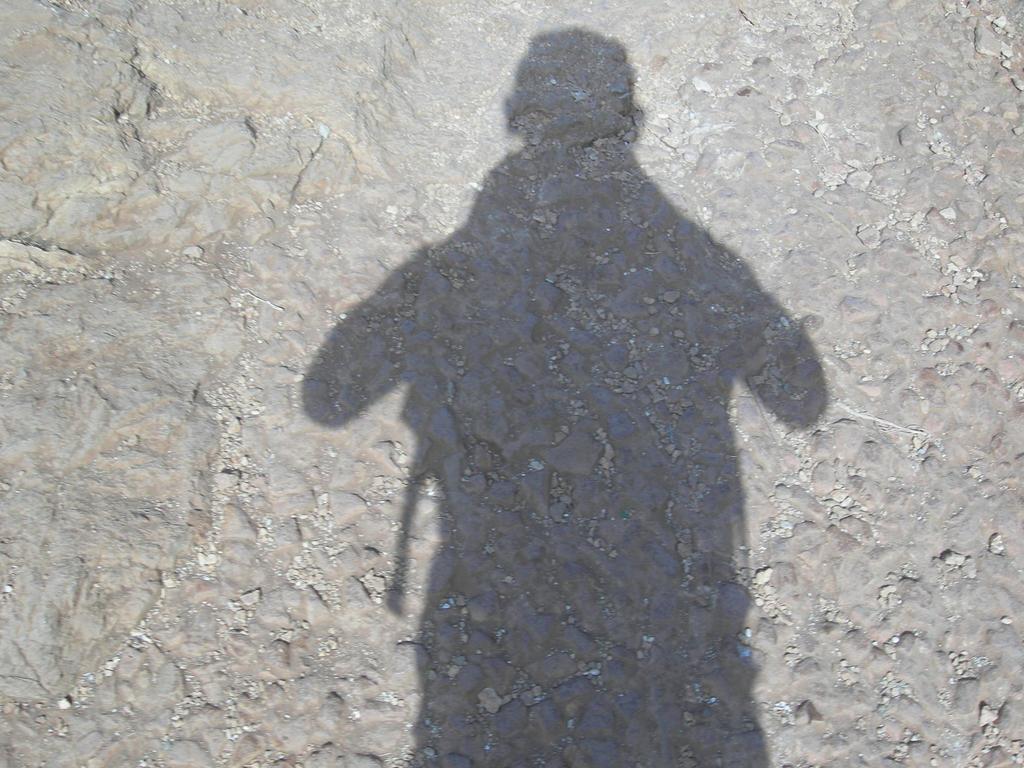How would you summarize this image in a sentence or two? In this image we can see a shadow of a person and rock surface. 